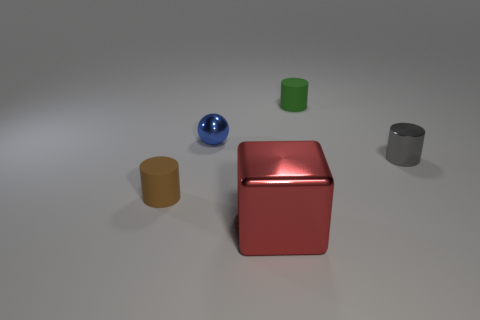What color is the small rubber cylinder that is in front of the matte object behind the cylinder in front of the gray object?
Give a very brief answer. Brown. What size is the thing that is left of the large cube and in front of the small blue shiny object?
Offer a very short reply. Small. What number of other objects are the same shape as the red object?
Ensure brevity in your answer.  0. What number of balls are either brown rubber objects or tiny matte objects?
Make the answer very short. 0. Are there any small metallic cylinders that are to the left of the small matte object in front of the tiny matte cylinder on the right side of the small brown matte cylinder?
Provide a succinct answer. No. What color is the other rubber object that is the same shape as the small green object?
Offer a terse response. Brown. How many gray objects are small balls or tiny metal cylinders?
Make the answer very short. 1. There is a small thing on the right side of the small rubber cylinder behind the brown rubber cylinder; what is it made of?
Your answer should be compact. Metal. Is the shape of the blue metallic object the same as the small green object?
Offer a terse response. No. There is a ball that is the same size as the brown cylinder; what color is it?
Provide a succinct answer. Blue. 